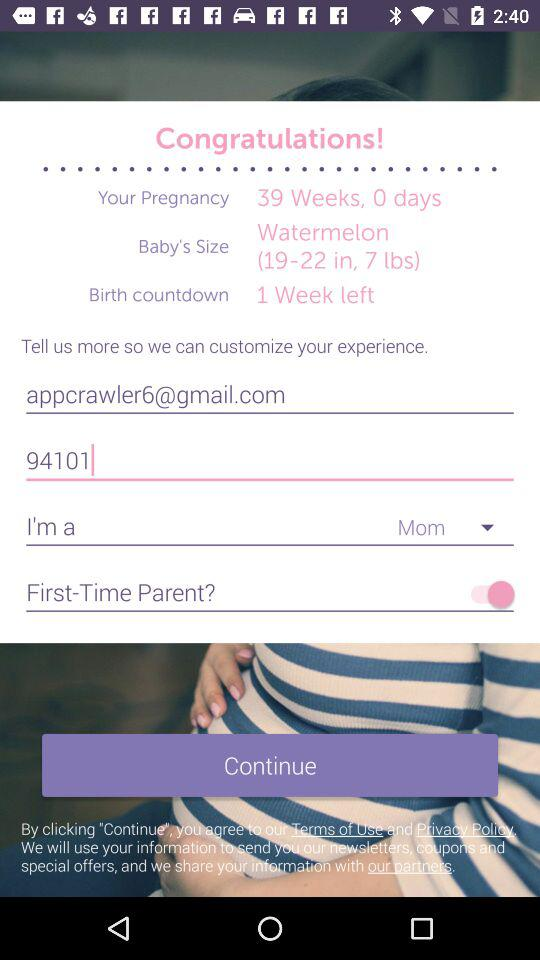What is the size of the baby? The size of the baby is 19–22 inches and 7 lbs. 